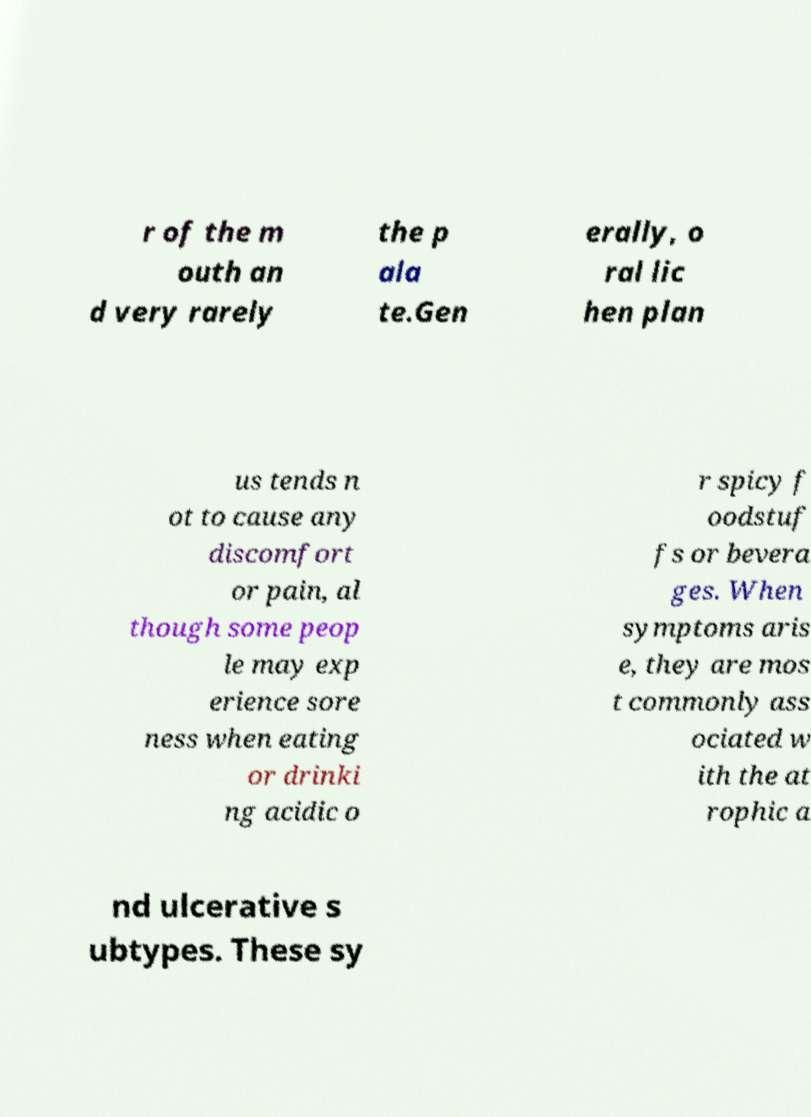Could you extract and type out the text from this image? r of the m outh an d very rarely the p ala te.Gen erally, o ral lic hen plan us tends n ot to cause any discomfort or pain, al though some peop le may exp erience sore ness when eating or drinki ng acidic o r spicy f oodstuf fs or bevera ges. When symptoms aris e, they are mos t commonly ass ociated w ith the at rophic a nd ulcerative s ubtypes. These sy 